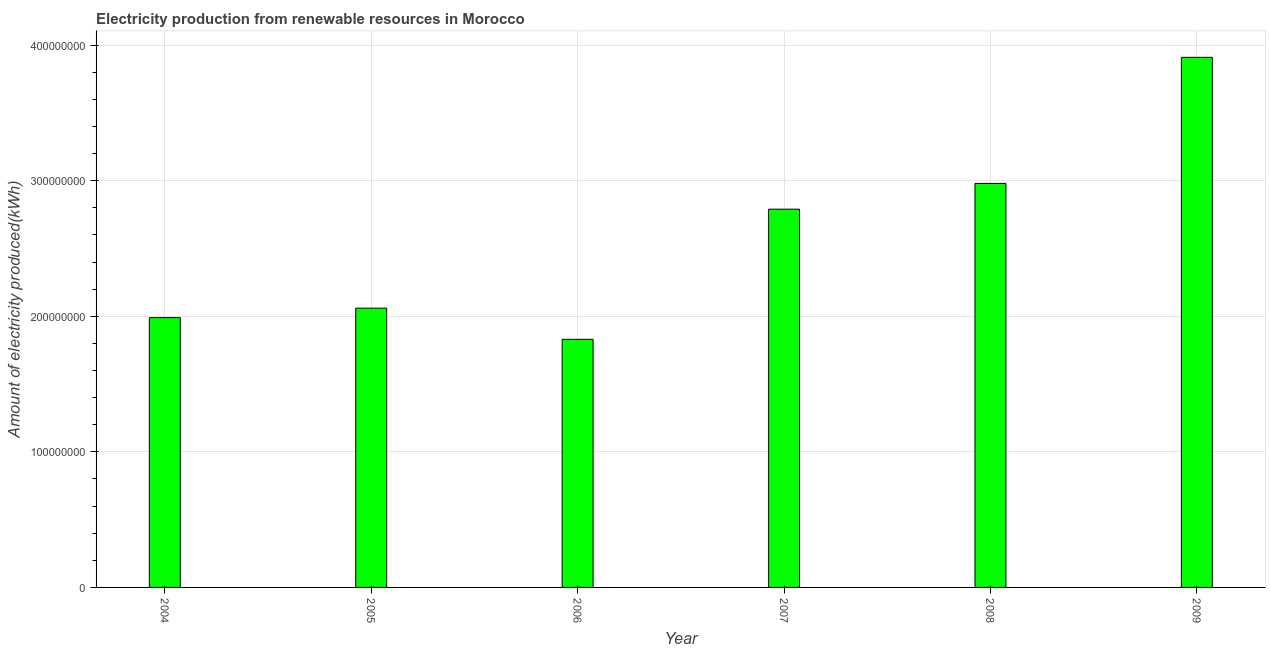Does the graph contain any zero values?
Provide a short and direct response. No. What is the title of the graph?
Provide a short and direct response. Electricity production from renewable resources in Morocco. What is the label or title of the X-axis?
Provide a succinct answer. Year. What is the label or title of the Y-axis?
Provide a short and direct response. Amount of electricity produced(kWh). What is the amount of electricity produced in 2008?
Offer a very short reply. 2.98e+08. Across all years, what is the maximum amount of electricity produced?
Your response must be concise. 3.91e+08. Across all years, what is the minimum amount of electricity produced?
Make the answer very short. 1.83e+08. What is the sum of the amount of electricity produced?
Your answer should be very brief. 1.56e+09. What is the difference between the amount of electricity produced in 2006 and 2009?
Ensure brevity in your answer.  -2.08e+08. What is the average amount of electricity produced per year?
Your response must be concise. 2.59e+08. What is the median amount of electricity produced?
Ensure brevity in your answer.  2.42e+08. What is the ratio of the amount of electricity produced in 2005 to that in 2006?
Provide a succinct answer. 1.13. Is the difference between the amount of electricity produced in 2004 and 2005 greater than the difference between any two years?
Provide a succinct answer. No. What is the difference between the highest and the second highest amount of electricity produced?
Provide a short and direct response. 9.30e+07. What is the difference between the highest and the lowest amount of electricity produced?
Make the answer very short. 2.08e+08. In how many years, is the amount of electricity produced greater than the average amount of electricity produced taken over all years?
Your answer should be compact. 3. How many bars are there?
Offer a terse response. 6. How many years are there in the graph?
Your response must be concise. 6. What is the difference between two consecutive major ticks on the Y-axis?
Provide a short and direct response. 1.00e+08. Are the values on the major ticks of Y-axis written in scientific E-notation?
Your response must be concise. No. What is the Amount of electricity produced(kWh) in 2004?
Provide a short and direct response. 1.99e+08. What is the Amount of electricity produced(kWh) in 2005?
Your response must be concise. 2.06e+08. What is the Amount of electricity produced(kWh) of 2006?
Your answer should be compact. 1.83e+08. What is the Amount of electricity produced(kWh) of 2007?
Your answer should be very brief. 2.79e+08. What is the Amount of electricity produced(kWh) of 2008?
Provide a succinct answer. 2.98e+08. What is the Amount of electricity produced(kWh) of 2009?
Your answer should be very brief. 3.91e+08. What is the difference between the Amount of electricity produced(kWh) in 2004 and 2005?
Your answer should be compact. -7.00e+06. What is the difference between the Amount of electricity produced(kWh) in 2004 and 2006?
Make the answer very short. 1.60e+07. What is the difference between the Amount of electricity produced(kWh) in 2004 and 2007?
Ensure brevity in your answer.  -8.00e+07. What is the difference between the Amount of electricity produced(kWh) in 2004 and 2008?
Keep it short and to the point. -9.90e+07. What is the difference between the Amount of electricity produced(kWh) in 2004 and 2009?
Offer a very short reply. -1.92e+08. What is the difference between the Amount of electricity produced(kWh) in 2005 and 2006?
Your response must be concise. 2.30e+07. What is the difference between the Amount of electricity produced(kWh) in 2005 and 2007?
Ensure brevity in your answer.  -7.30e+07. What is the difference between the Amount of electricity produced(kWh) in 2005 and 2008?
Ensure brevity in your answer.  -9.20e+07. What is the difference between the Amount of electricity produced(kWh) in 2005 and 2009?
Make the answer very short. -1.85e+08. What is the difference between the Amount of electricity produced(kWh) in 2006 and 2007?
Make the answer very short. -9.60e+07. What is the difference between the Amount of electricity produced(kWh) in 2006 and 2008?
Offer a very short reply. -1.15e+08. What is the difference between the Amount of electricity produced(kWh) in 2006 and 2009?
Your answer should be compact. -2.08e+08. What is the difference between the Amount of electricity produced(kWh) in 2007 and 2008?
Give a very brief answer. -1.90e+07. What is the difference between the Amount of electricity produced(kWh) in 2007 and 2009?
Offer a terse response. -1.12e+08. What is the difference between the Amount of electricity produced(kWh) in 2008 and 2009?
Give a very brief answer. -9.30e+07. What is the ratio of the Amount of electricity produced(kWh) in 2004 to that in 2006?
Your response must be concise. 1.09. What is the ratio of the Amount of electricity produced(kWh) in 2004 to that in 2007?
Your answer should be very brief. 0.71. What is the ratio of the Amount of electricity produced(kWh) in 2004 to that in 2008?
Your answer should be compact. 0.67. What is the ratio of the Amount of electricity produced(kWh) in 2004 to that in 2009?
Offer a terse response. 0.51. What is the ratio of the Amount of electricity produced(kWh) in 2005 to that in 2006?
Make the answer very short. 1.13. What is the ratio of the Amount of electricity produced(kWh) in 2005 to that in 2007?
Give a very brief answer. 0.74. What is the ratio of the Amount of electricity produced(kWh) in 2005 to that in 2008?
Offer a very short reply. 0.69. What is the ratio of the Amount of electricity produced(kWh) in 2005 to that in 2009?
Offer a terse response. 0.53. What is the ratio of the Amount of electricity produced(kWh) in 2006 to that in 2007?
Make the answer very short. 0.66. What is the ratio of the Amount of electricity produced(kWh) in 2006 to that in 2008?
Your response must be concise. 0.61. What is the ratio of the Amount of electricity produced(kWh) in 2006 to that in 2009?
Your response must be concise. 0.47. What is the ratio of the Amount of electricity produced(kWh) in 2007 to that in 2008?
Your response must be concise. 0.94. What is the ratio of the Amount of electricity produced(kWh) in 2007 to that in 2009?
Ensure brevity in your answer.  0.71. What is the ratio of the Amount of electricity produced(kWh) in 2008 to that in 2009?
Your answer should be compact. 0.76. 